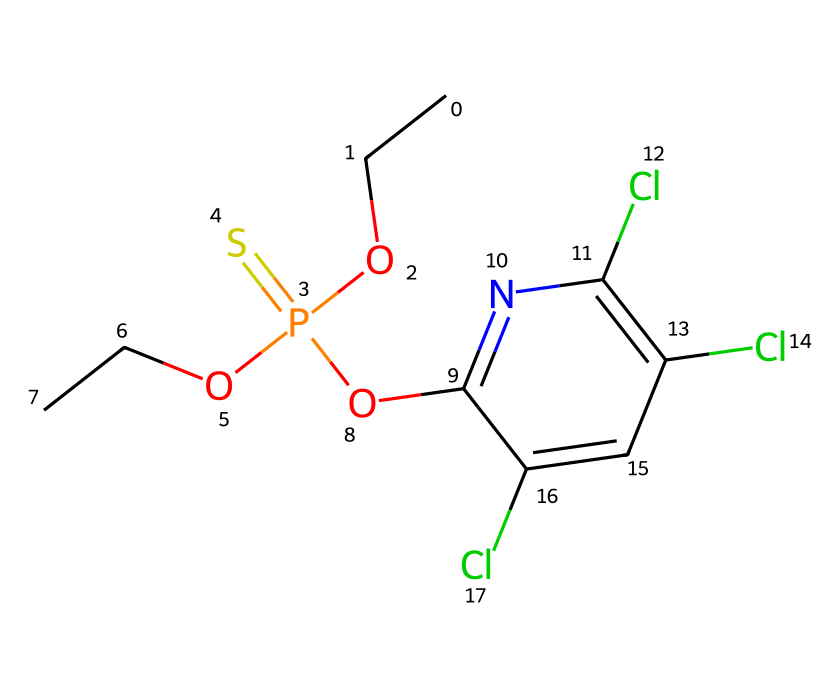What is the molecular formula of chlorpyrifos? By analyzing the SMILES representation, we can identify the number of each type of atom present: there are 12 carbon (C) atoms, 14 hydrogen (H) atoms, 4 chlorine (Cl) atoms, 1 phosphorus (P) atom, and 1 oxygen (O) atom. Putting this together gives us the molecular formula of C12H14Cl4NO3PS.
Answer: C12H14Cl4NO3PS How many chlorine atoms are present in the structure? In the SMILES representation, we can identify the occurrences of 'Cl', which indicates chlorine atoms. There are three instances of 'Cl'.
Answer: 3 Which functional group is present in chlorpyrifos? In the structure, the presence of phosphorus and sulfur atoms connected with the oxygen atom indicates the presence of a phosphorothioate functional group. This is characteristic of organophosphate insecticides.
Answer: phosphorothioate What is the role of chlorine in this pesticide? Chlorine atoms in organophosphate pesticides like chlorpyrifos typically increase the lipid solubility and enhance the insecticidal activity against pests.
Answer: increase activity Is chlorpyrifos commonly used in agriculture? Given the chemical's classification as an organophosphate insecticide and its distinct structure known for effective pest control, we can affirm that it is indeed widely used in agricultural settings.
Answer: yes What property does the phosphorus atom contribute to chlorpyrifos? The phosphorus atom plays a crucial role by contributing to the neurotoxic properties of the compound, which disrupts the nervous systems of pests.
Answer: neurotoxic property How many oxygen atoms are included in chlorpyrifos? The SMILES representation contains the 'O' symbols that denote oxygen atoms, revealing that there are three oxygen atoms present in the structure.
Answer: 3 